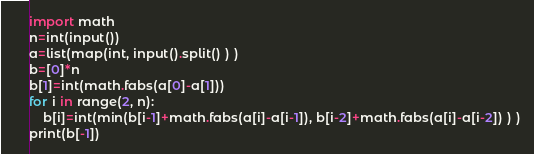Convert code to text. <code><loc_0><loc_0><loc_500><loc_500><_Python_>import math
n=int(input())
a=list(map(int, input().split() ) )
b=[0]*n
b[1]=int(math.fabs(a[0]-a[1]))
for i in range(2, n):
    b[i]=int(min(b[i-1]+math.fabs(a[i]-a[i-1]), b[i-2]+math.fabs(a[i]-a[i-2]) ) )
print(b[-1])</code> 